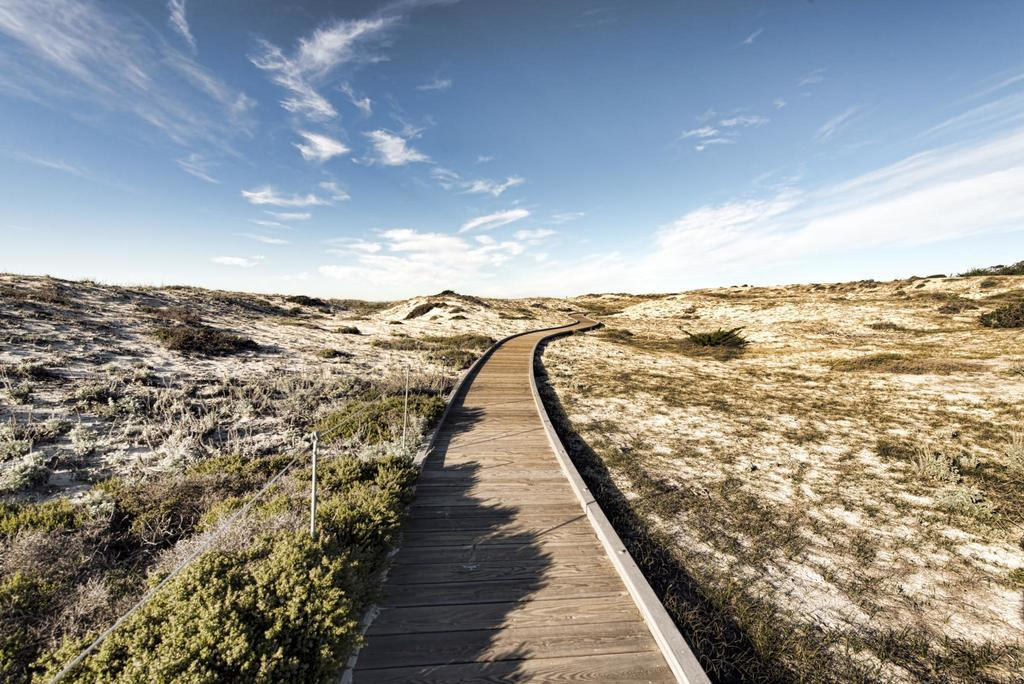What type of path is present in the image? There is a wooden path in the image. What can be seen near the path? Plants are visible near the path. What is visible beneath the path? The ground is visible in the image. What is visible in the sky in the background of the image? There are clouds and the sky is blue in the background of the image. How many apples are hanging from the trees near the path? There are no apples visible in the image; only plants are mentioned. 